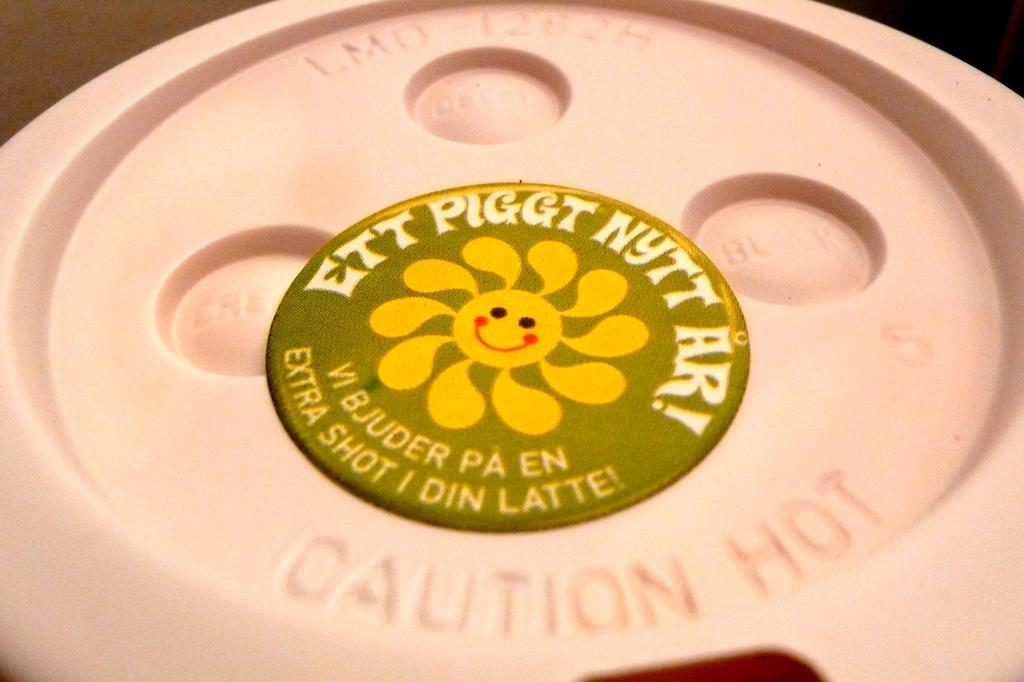What is labeled in the image? There is a label on an object in the image. What type of thread is being used to reduce friction on the desk in the image? There is no thread or desk present in the image; the only fact provided is that there is a label on an object. 